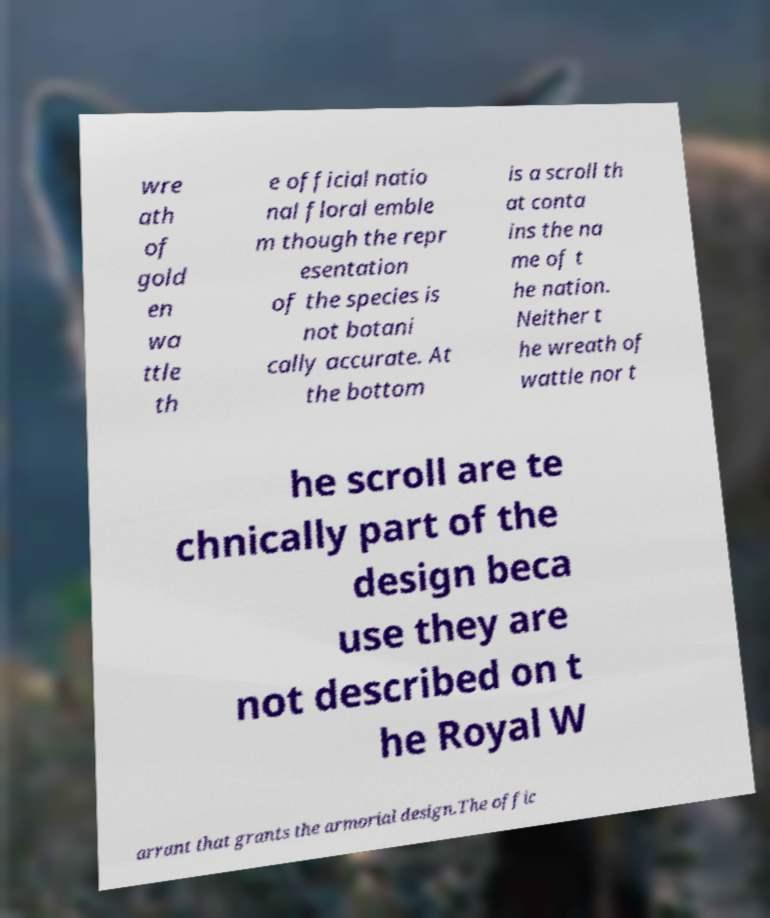Please read and relay the text visible in this image. What does it say? wre ath of gold en wa ttle th e official natio nal floral emble m though the repr esentation of the species is not botani cally accurate. At the bottom is a scroll th at conta ins the na me of t he nation. Neither t he wreath of wattle nor t he scroll are te chnically part of the design beca use they are not described on t he Royal W arrant that grants the armorial design.The offic 